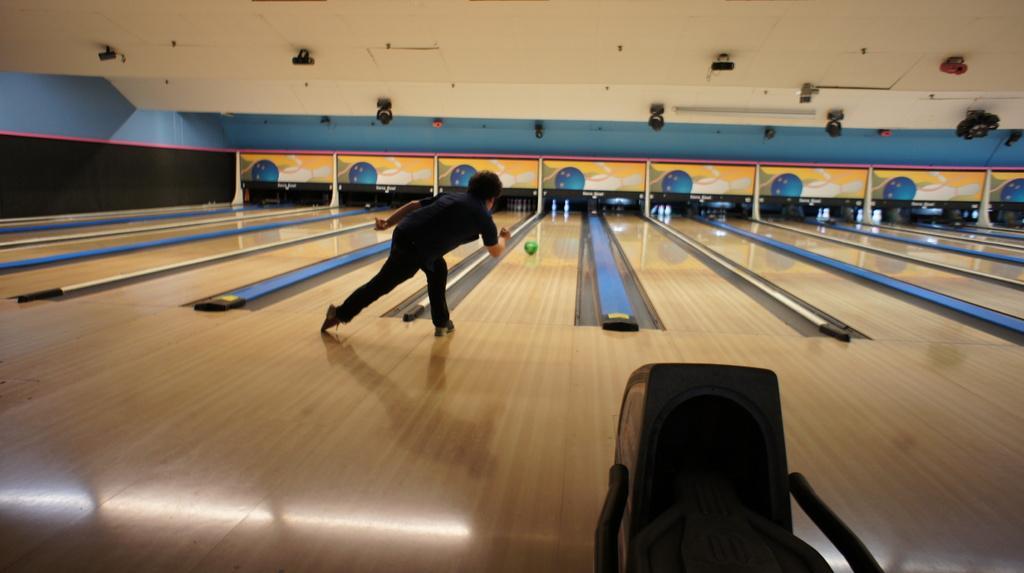Can you describe this image briefly? In this image we can see a person is playing ball. Bottom of the image stand is there. The roof is in white color. The floor is furnished with wood. 